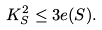Convert formula to latex. <formula><loc_0><loc_0><loc_500><loc_500>K _ { S } ^ { 2 } \leq 3 e ( S ) .</formula> 